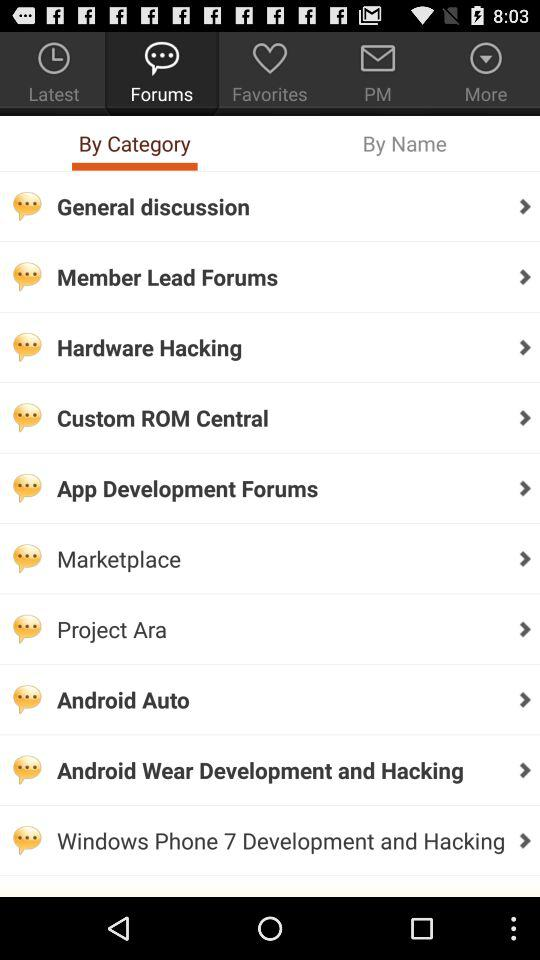How many forums are there?
Answer the question using a single word or phrase. 10 